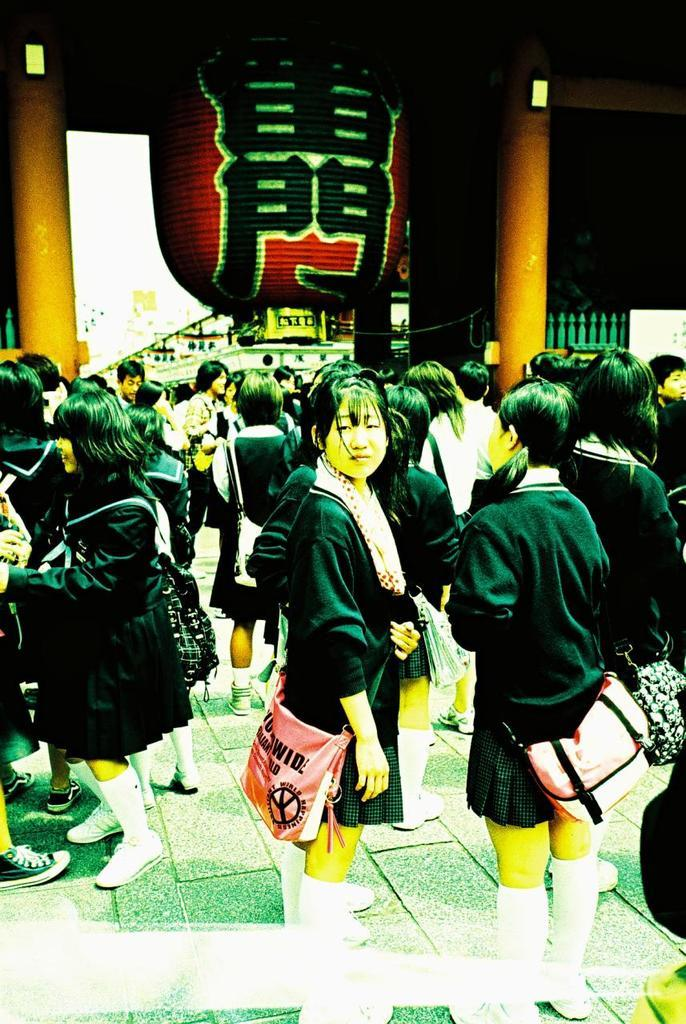How many people are in the image? There is a group of people in the image, but the exact number is not specified. What are the people doing in the image? The people are standing in the image. What are the people wearing that is visible in the image? The people are wearing bags in the image. What type of architectural features can be seen in the image? There are pillars and a grille visible in the image. Can you describe any other objects in the image? There are other unspecified objects in the image, but their details are not provided. How many geese are walking in the image? There are no geese present in the image. What type of fiction is being read by the people in the image? There is no indication that the people in the image are reading any fiction. 